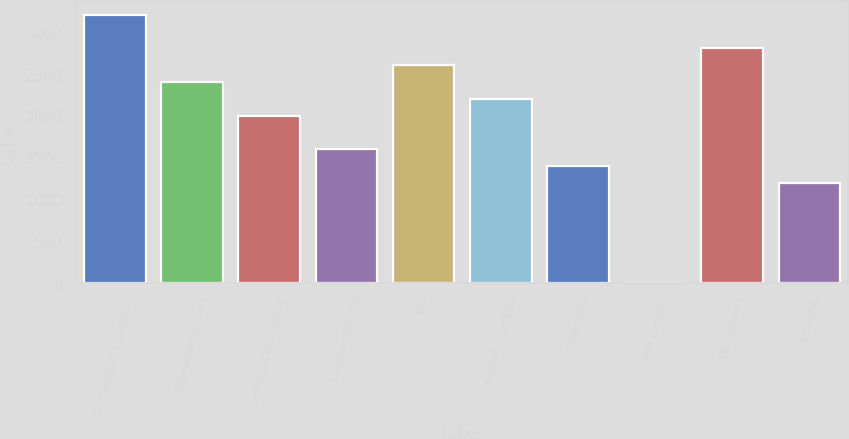Convert chart. <chart><loc_0><loc_0><loc_500><loc_500><bar_chart><fcel>As of December 31 (dollars in<fcel>Commercial real estate<fcel>Commercial and industrial<fcel>Equipment financing<fcel>Total<fcel>Residential mortgage<fcel>Home equity<fcel>Other consumer<fcel>Total originated<fcel>Residential<nl><fcel>3220.74<fcel>2415.58<fcel>2013<fcel>1610.42<fcel>2616.87<fcel>2214.29<fcel>1409.13<fcel>0.1<fcel>2818.16<fcel>1207.84<nl></chart> 